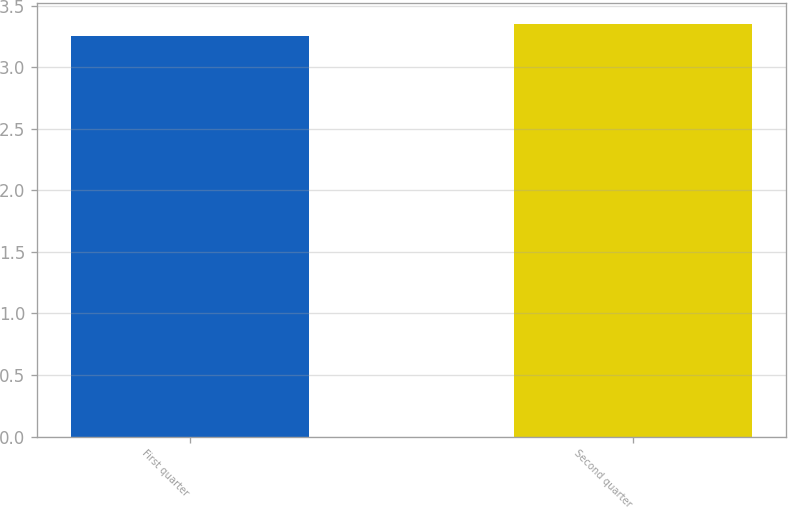Convert chart to OTSL. <chart><loc_0><loc_0><loc_500><loc_500><bar_chart><fcel>First quarter<fcel>Second quarter<nl><fcel>3.25<fcel>3.35<nl></chart> 